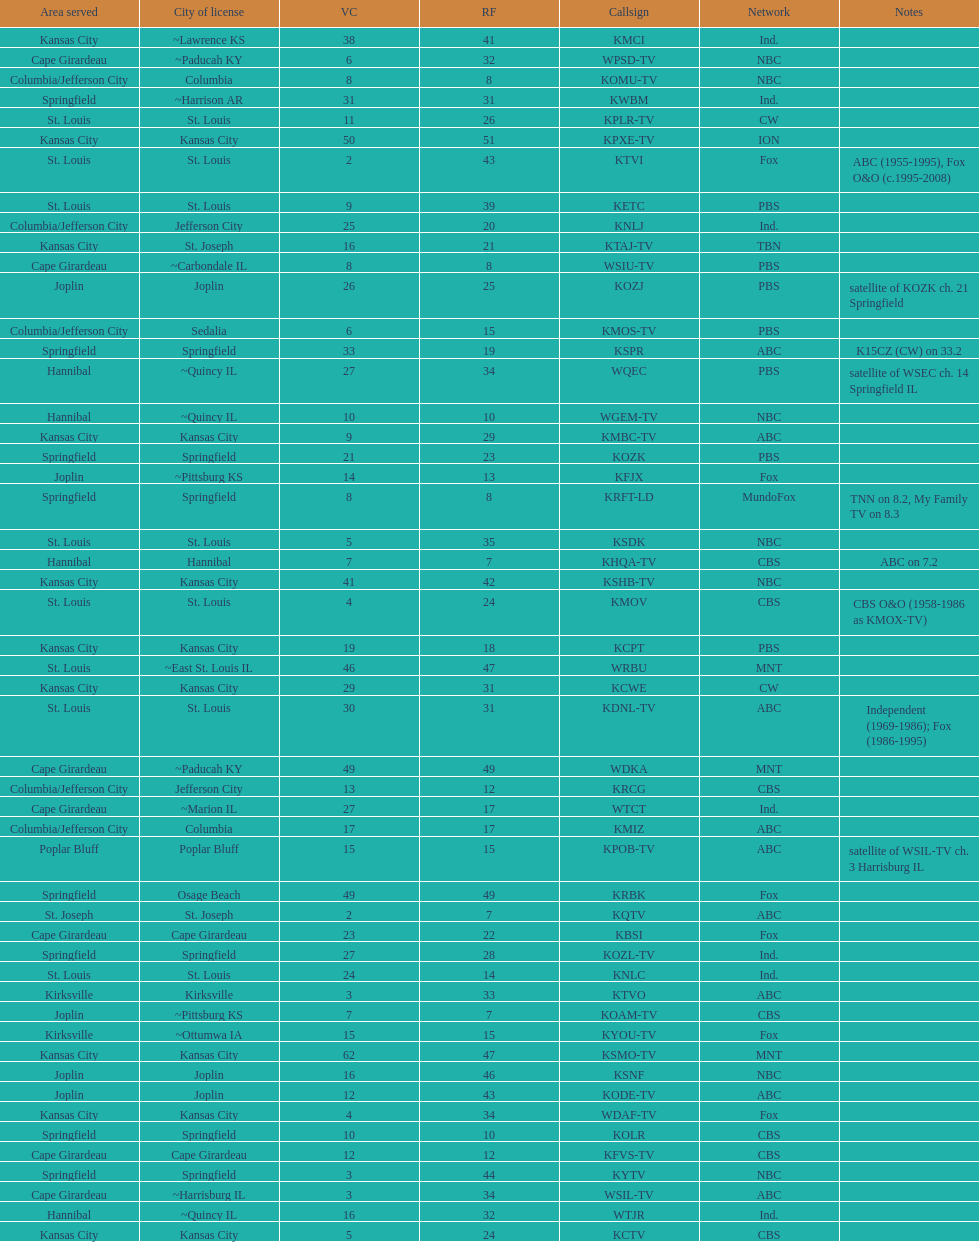What is the total number of cbs stations? 7. 